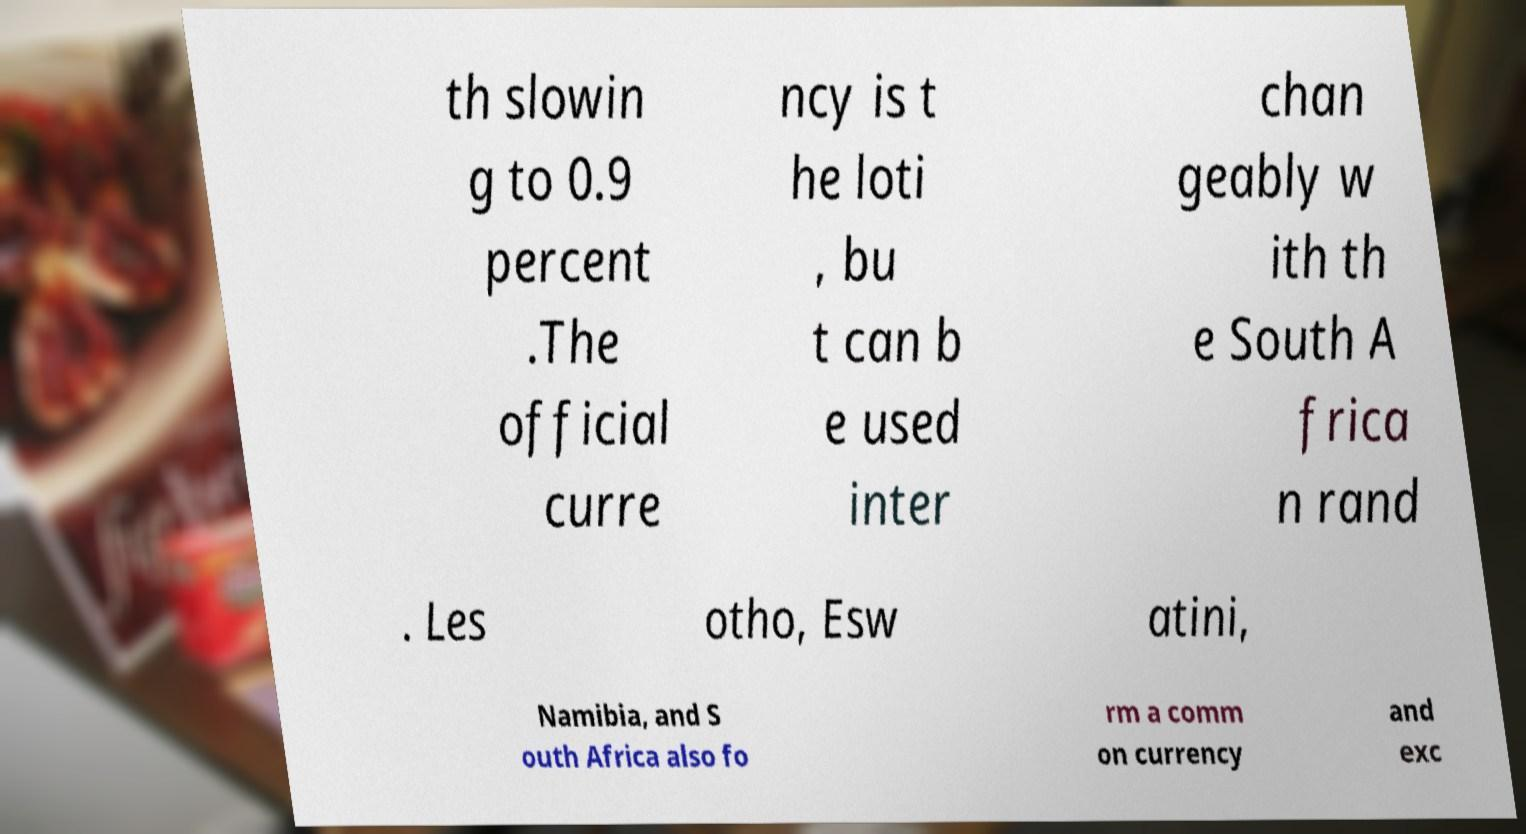Can you read and provide the text displayed in the image?This photo seems to have some interesting text. Can you extract and type it out for me? th slowin g to 0.9 percent .The official curre ncy is t he loti , bu t can b e used inter chan geably w ith th e South A frica n rand . Les otho, Esw atini, Namibia, and S outh Africa also fo rm a comm on currency and exc 